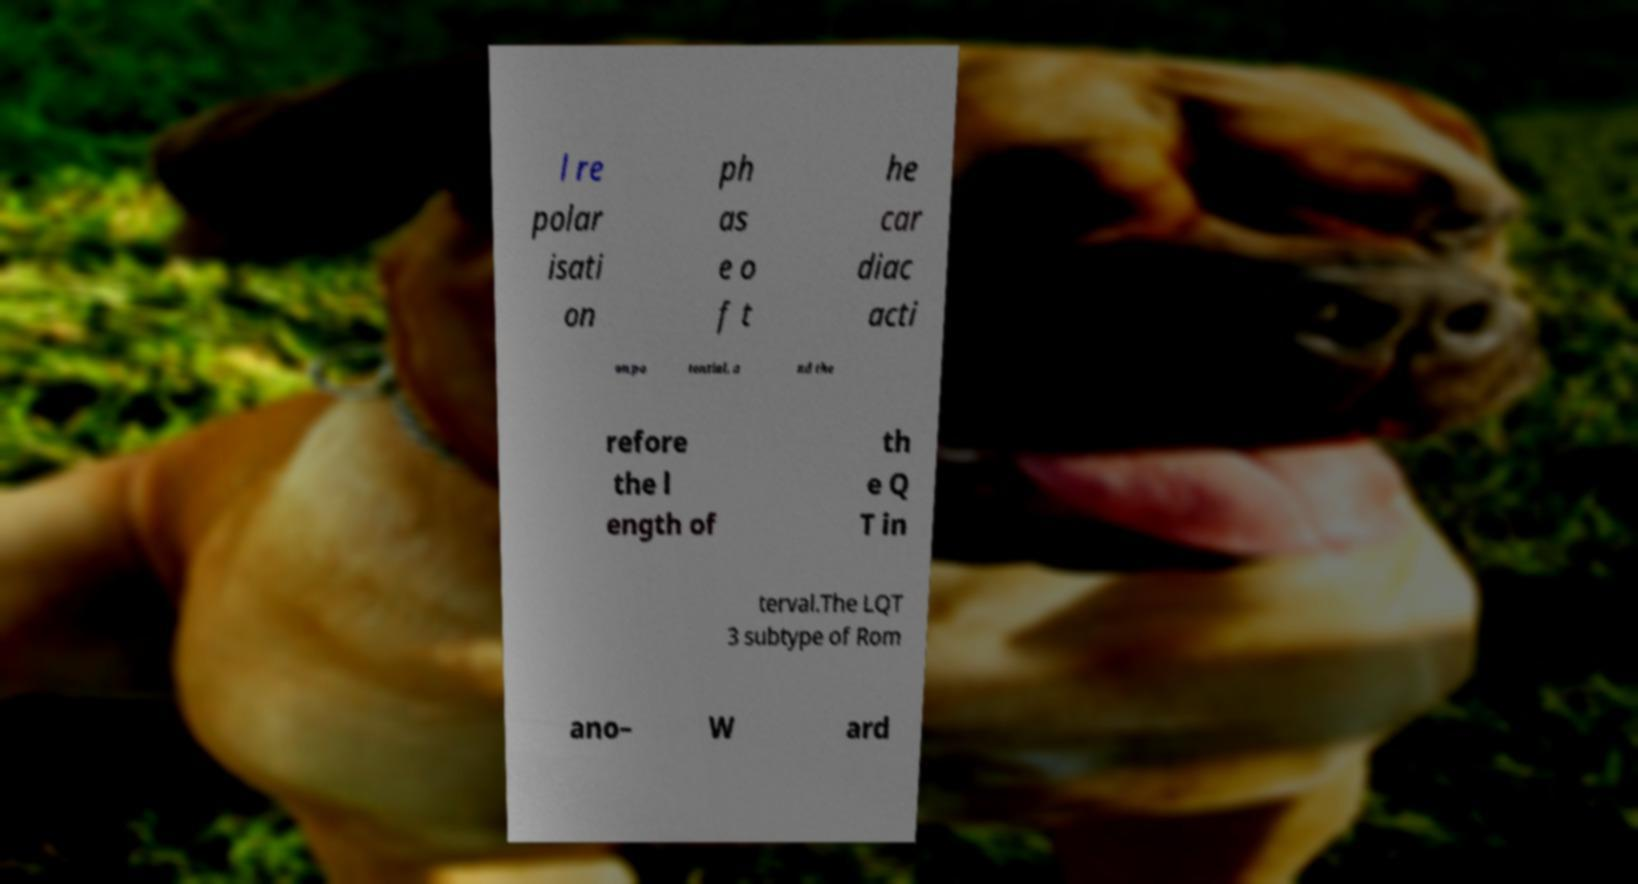Could you assist in decoding the text presented in this image and type it out clearly? l re polar isati on ph as e o f t he car diac acti on po tential, a nd the refore the l ength of th e Q T in terval.The LQT 3 subtype of Rom ano– W ard 